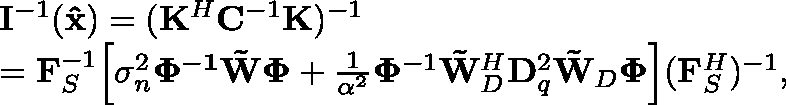<formula> <loc_0><loc_0><loc_500><loc_500>\begin{array} { r l } & { { I ^ { - 1 } ( { \hat { x } } ) } = ( { K ^ { H } } { C ^ { - 1 } } { K } ) ^ { - 1 } } \\ & { = F _ { S } ^ { - 1 } \left [ \sigma _ { n } ^ { 2 } \mathbf { \Phi } ^ { - 1 } \tilde { W } \Phi + \frac { 1 } { \alpha ^ { 2 } } \Phi ^ { - 1 } \tilde { W } _ { D } ^ { H } D _ { q } ^ { 2 } \tilde { W } _ { D } \Phi \right ] ( F _ { S } ^ { H } ) ^ { - 1 } , } \end{array}</formula> 